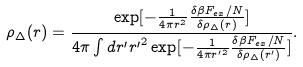<formula> <loc_0><loc_0><loc_500><loc_500>\rho _ { \Delta } ( r ) = \frac { \exp [ - \frac { 1 } { 4 \pi r ^ { 2 } } \frac { \delta \beta F _ { e x } / N } { \delta \rho _ { \Delta } ( r ) } ] } { 4 \pi \int d r ^ { \prime } { r ^ { \prime } } ^ { 2 } \exp [ - \frac { 1 } { 4 \pi { r ^ { \prime } } ^ { 2 } } \frac { \delta \beta F _ { e x } / N } { \delta \rho _ { \Delta } ( r ^ { \prime } ) } ] } .</formula> 